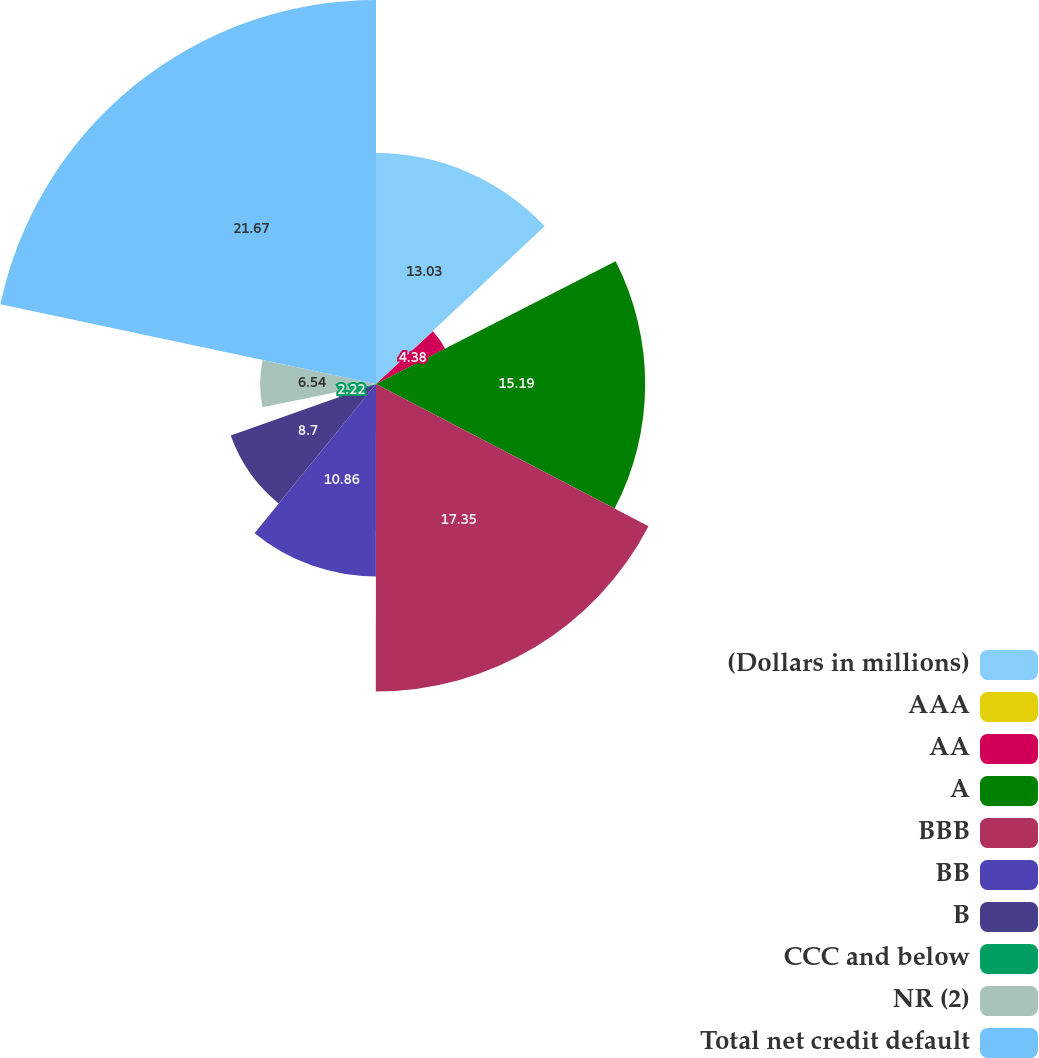Convert chart to OTSL. <chart><loc_0><loc_0><loc_500><loc_500><pie_chart><fcel>(Dollars in millions)<fcel>AAA<fcel>AA<fcel>A<fcel>BBB<fcel>BB<fcel>B<fcel>CCC and below<fcel>NR (2)<fcel>Total net credit default<nl><fcel>13.03%<fcel>0.06%<fcel>4.38%<fcel>15.19%<fcel>17.35%<fcel>10.86%<fcel>8.7%<fcel>2.22%<fcel>6.54%<fcel>21.67%<nl></chart> 